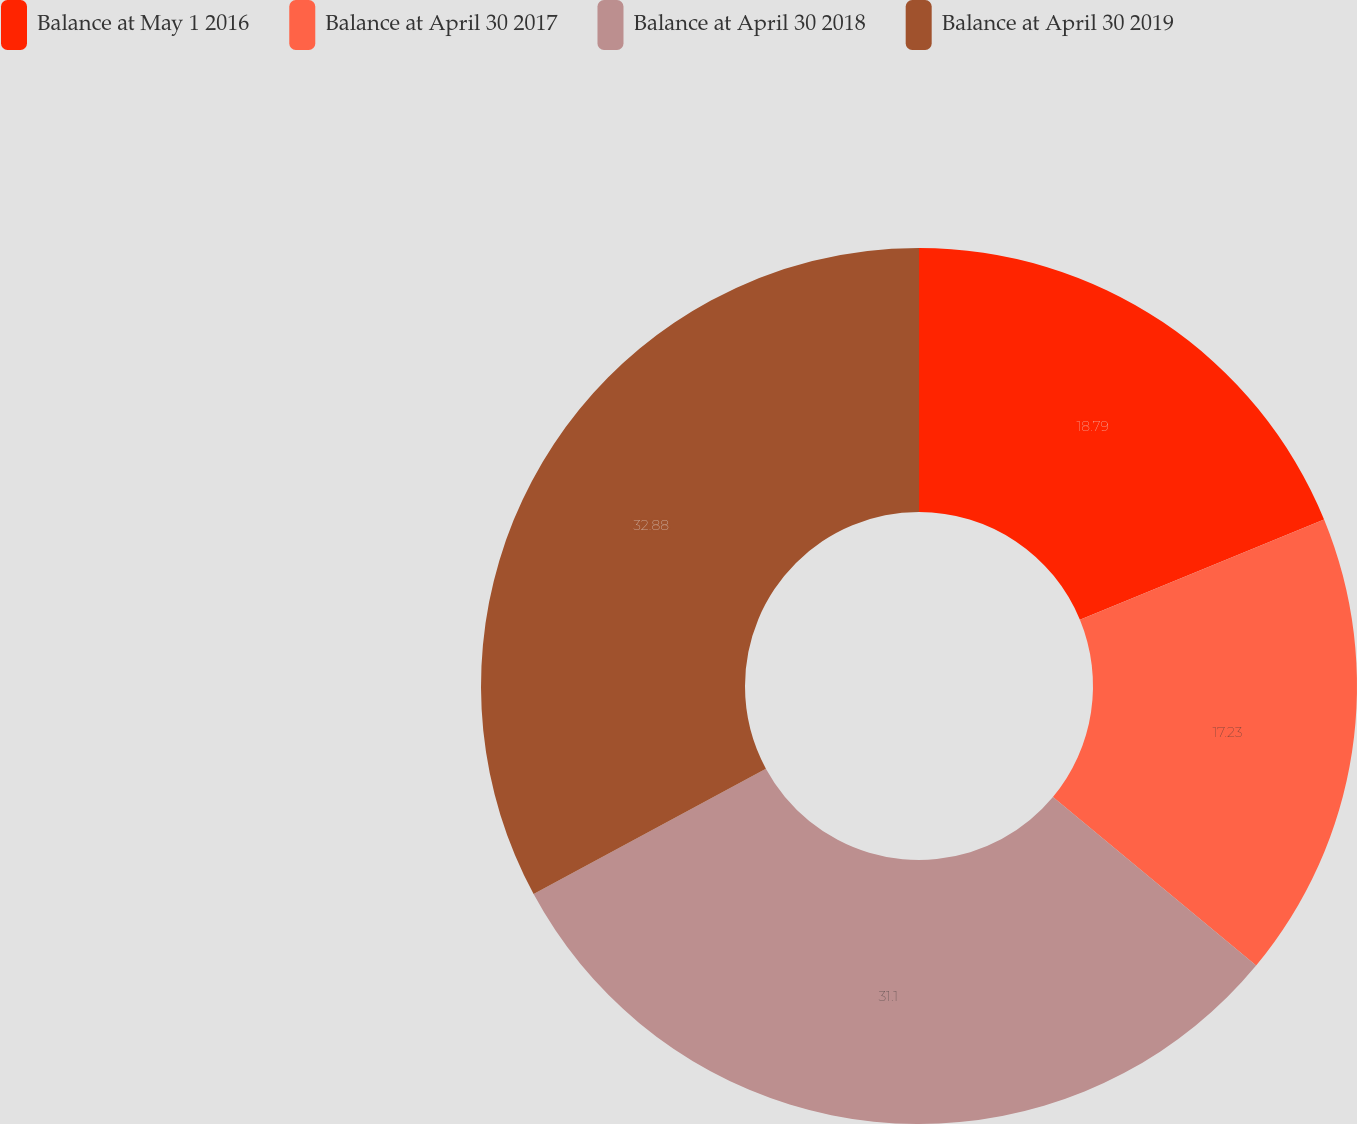Convert chart. <chart><loc_0><loc_0><loc_500><loc_500><pie_chart><fcel>Balance at May 1 2016<fcel>Balance at April 30 2017<fcel>Balance at April 30 2018<fcel>Balance at April 30 2019<nl><fcel>18.79%<fcel>17.23%<fcel>31.1%<fcel>32.88%<nl></chart> 